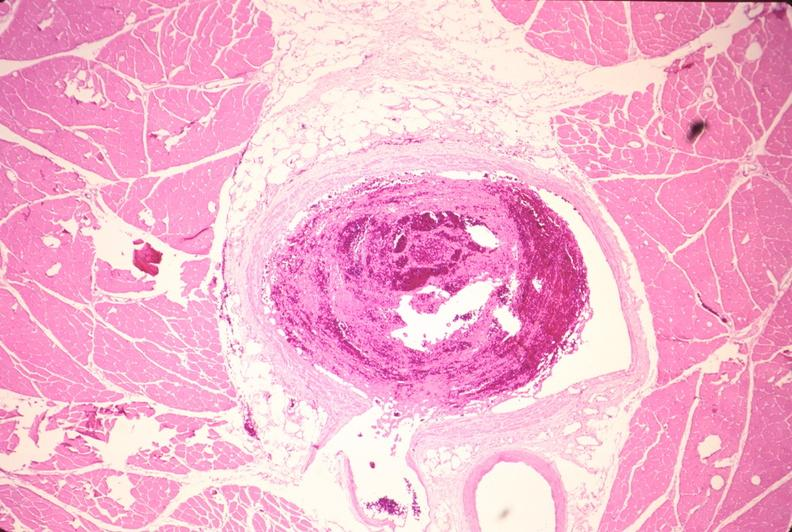what is present?
Answer the question using a single word or phrase. Cardiovascular 